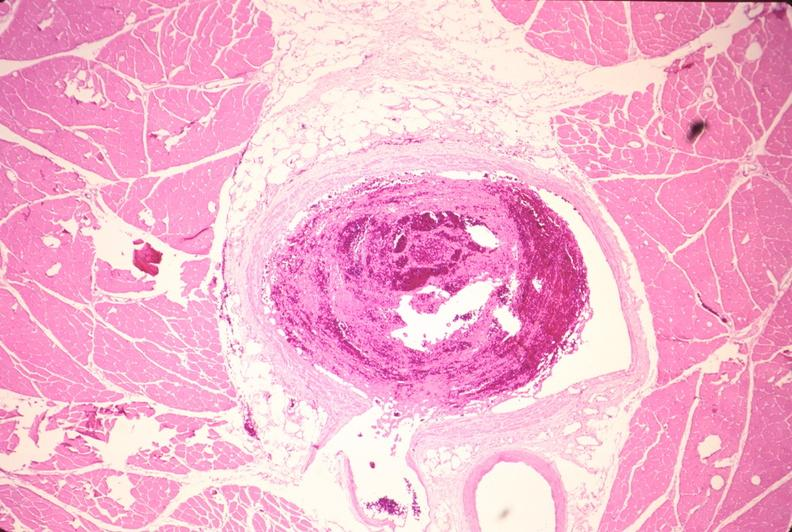what is present?
Answer the question using a single word or phrase. Cardiovascular 